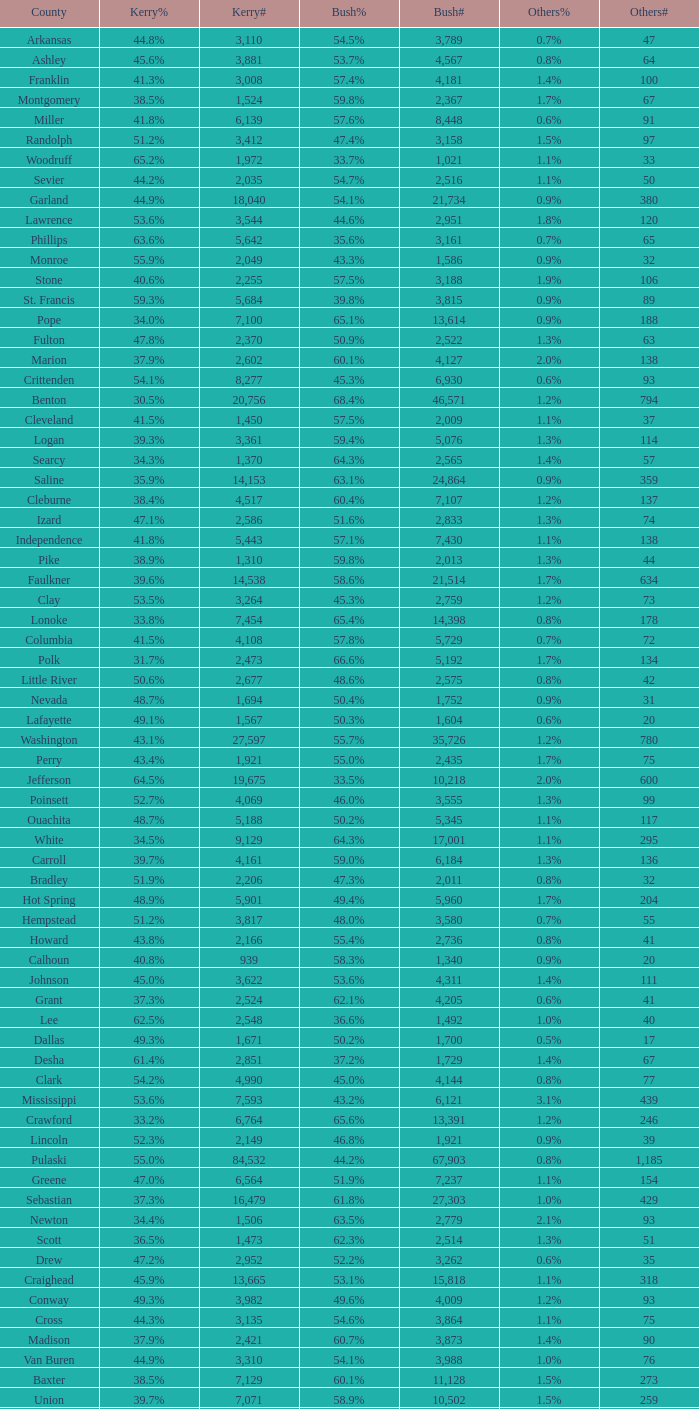What is the highest Bush#, when Others% is "1.7%", when Others# is less than 75, and when Kerry# is greater than 1,524? None. 